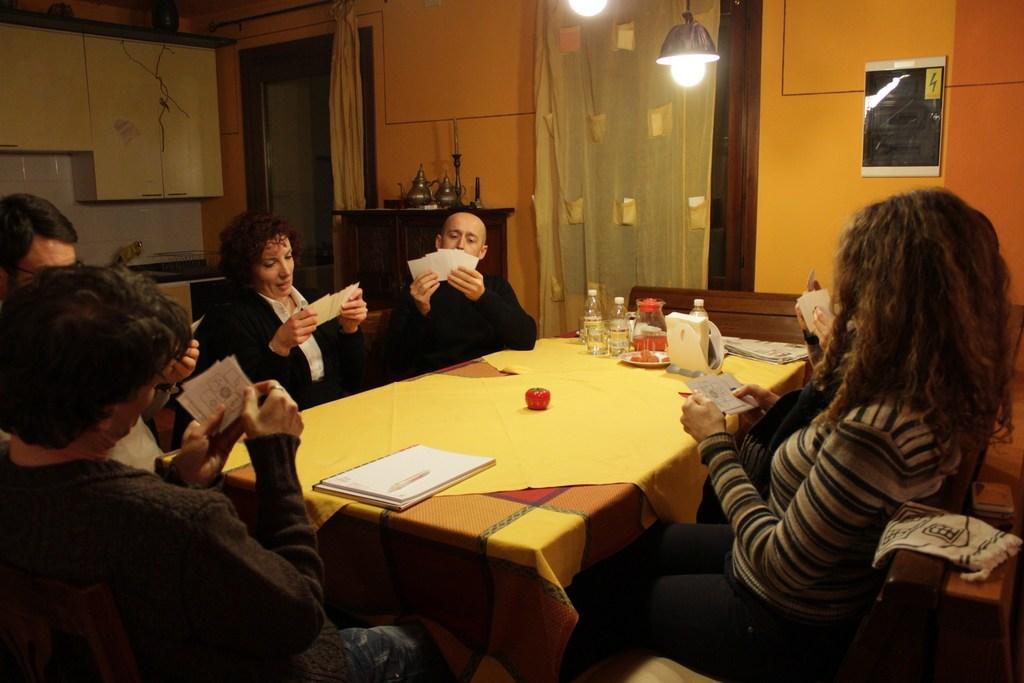In one or two sentences, can you explain what this image depicts? In this image people are playing cards. In the middle on the table there are book, bottles,glasses,jug, napkin, paper. Around the table on chairs people are sitting. In the background on the wall there are curtains, there is a cupboard on it there are jugs,candles, a counter over here. 